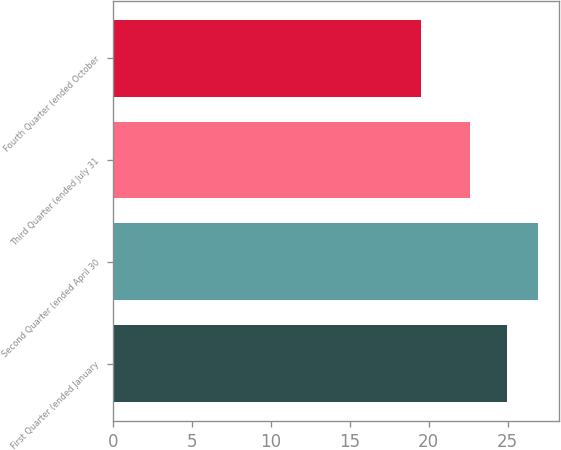<chart> <loc_0><loc_0><loc_500><loc_500><bar_chart><fcel>First Quarter (ended January<fcel>Second Quarter (ended April 30<fcel>Third Quarter (ended July 31<fcel>Fourth Quarter (ended October<nl><fcel>24.97<fcel>26.91<fcel>22.63<fcel>19.51<nl></chart> 